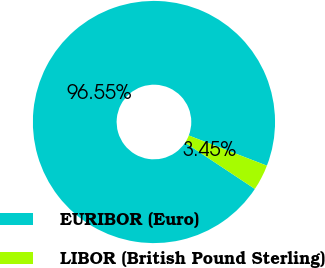Convert chart to OTSL. <chart><loc_0><loc_0><loc_500><loc_500><pie_chart><fcel>EURIBOR (Euro)<fcel>LIBOR (British Pound Sterling)<nl><fcel>96.55%<fcel>3.45%<nl></chart> 